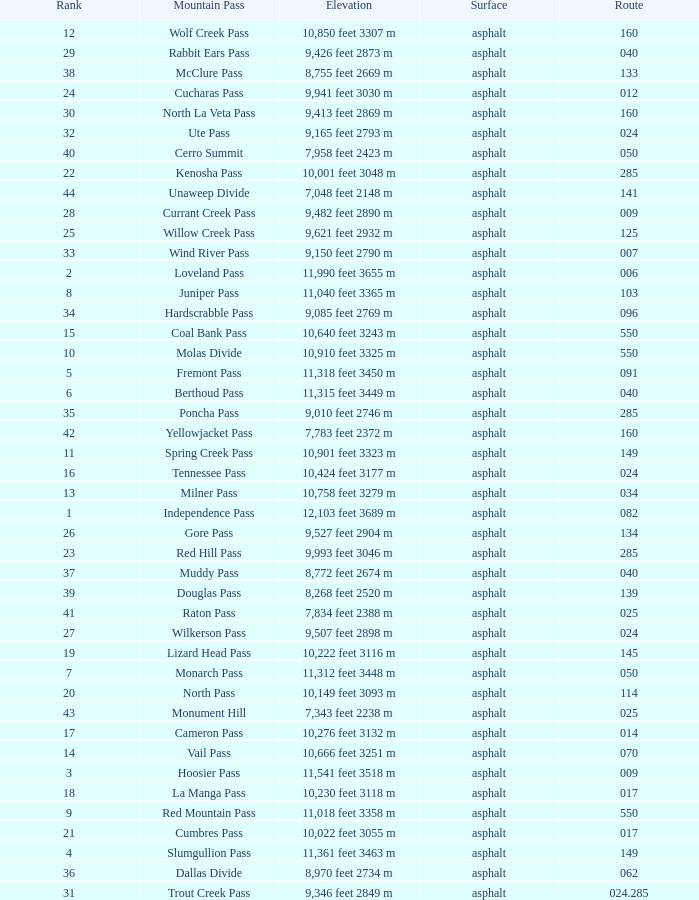What is the Elevation of the mountain on Route 62? 8,970 feet 2734 m. 